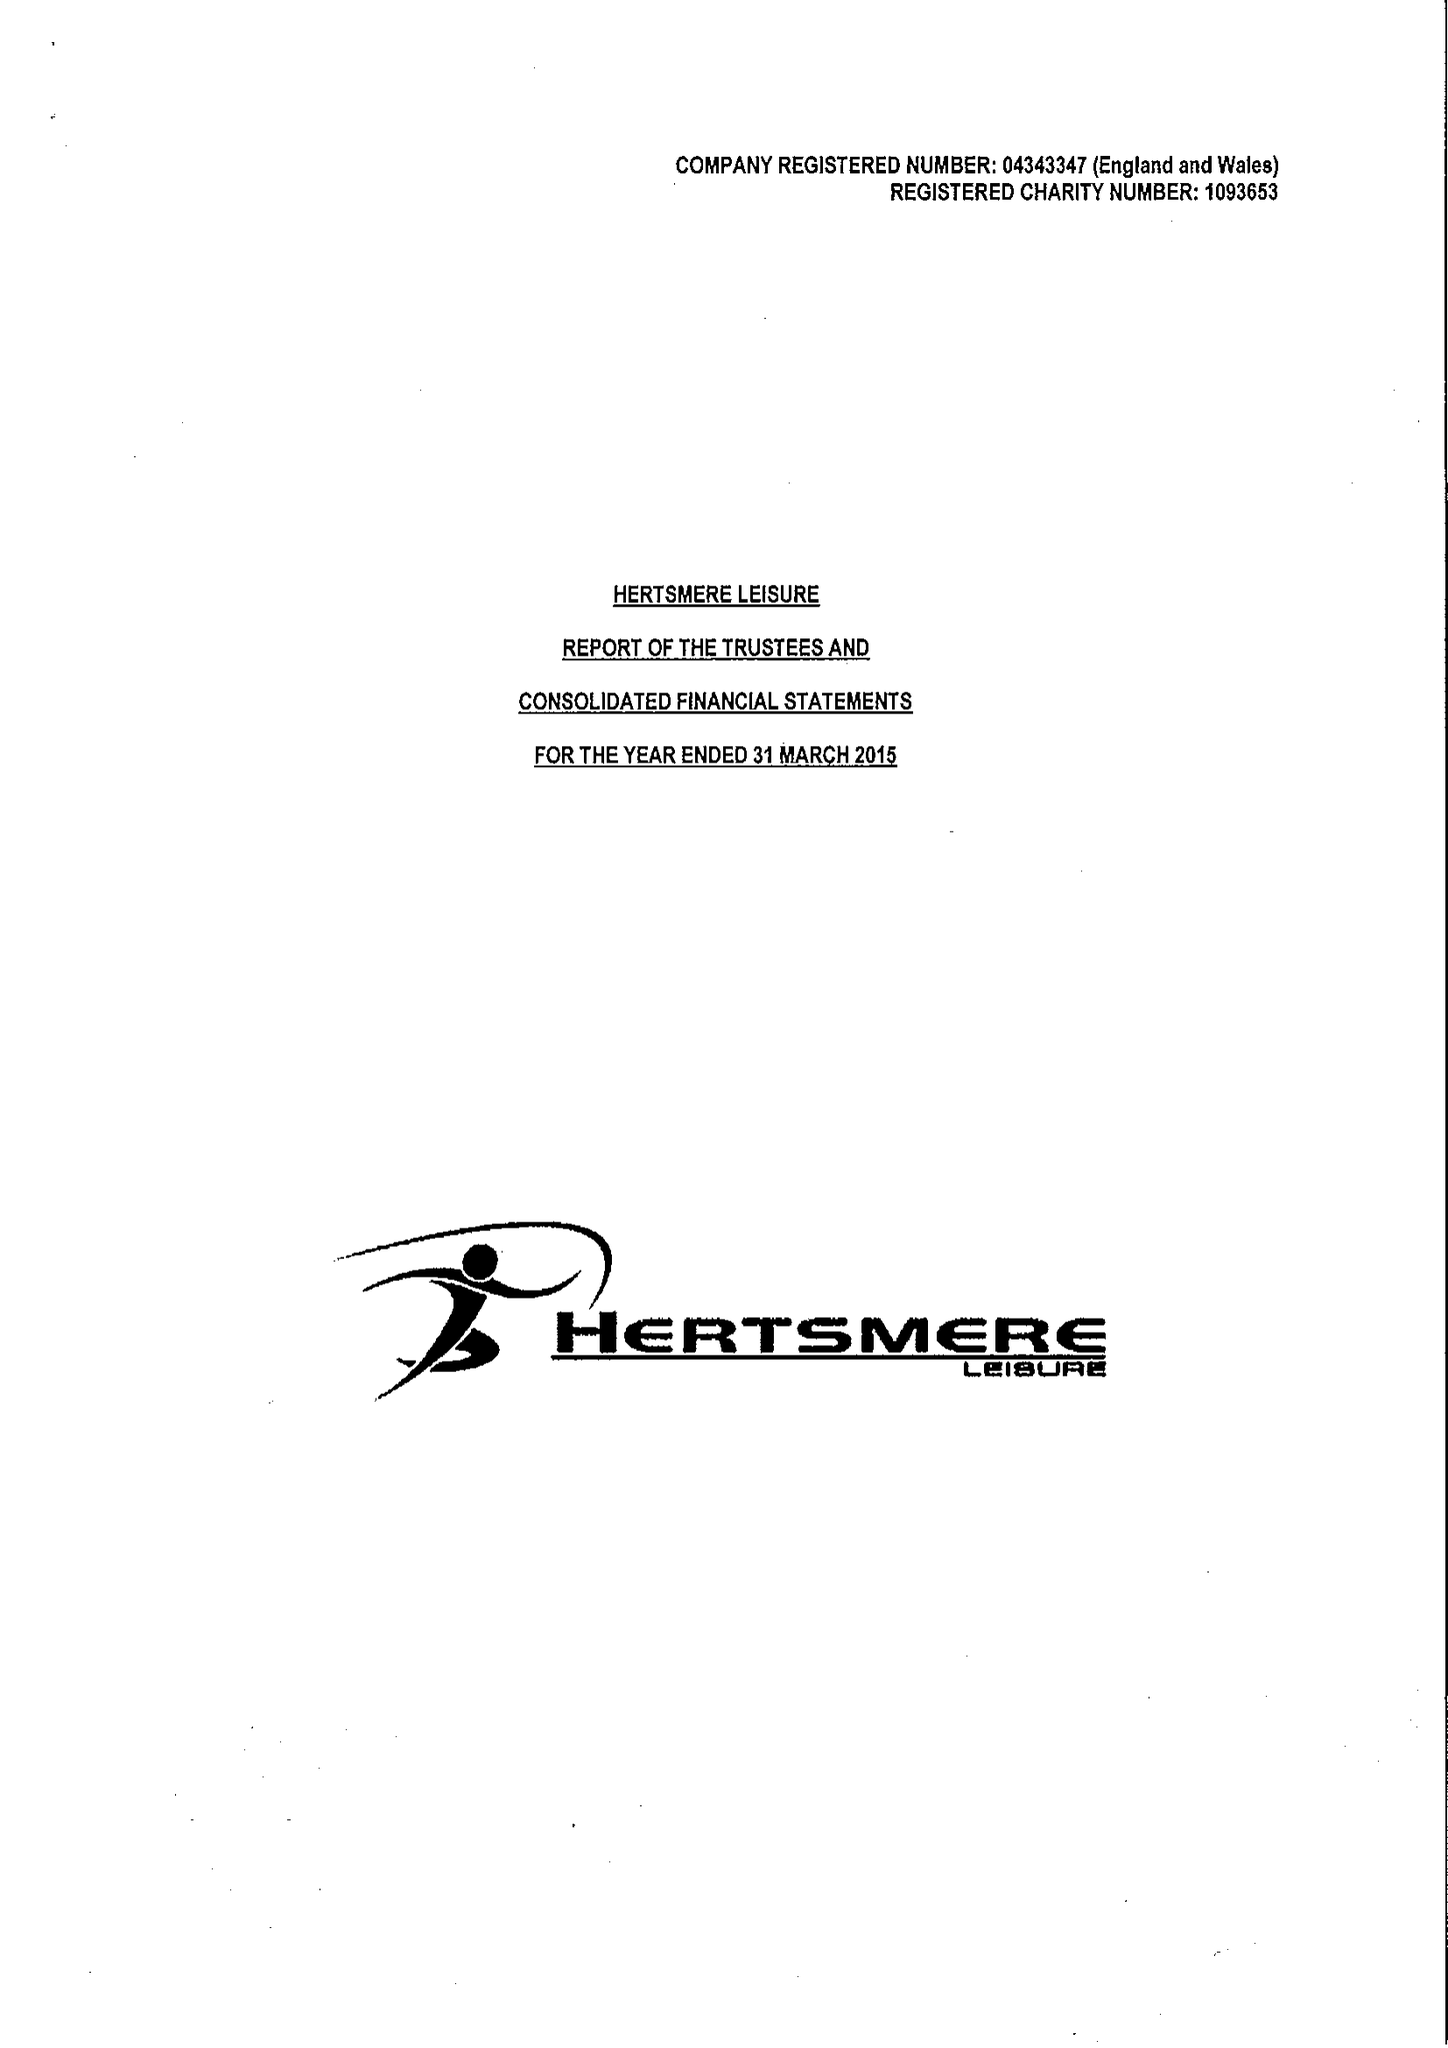What is the value for the report_date?
Answer the question using a single word or phrase. 2015-03-31 